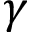<formula> <loc_0><loc_0><loc_500><loc_500>\gamma</formula> 